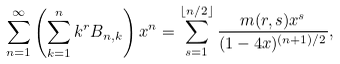Convert formula to latex. <formula><loc_0><loc_0><loc_500><loc_500>\sum _ { n = 1 } ^ { \infty } \left ( \sum _ { k = 1 } ^ { n } k ^ { r } B _ { n , k } \right ) x ^ { n } = \sum _ { s = 1 } ^ { \lfloor n / 2 \rfloor } \frac { m ( r , s ) x ^ { s } } { ( 1 - 4 x ) ^ { ( n + 1 ) / 2 } } ,</formula> 